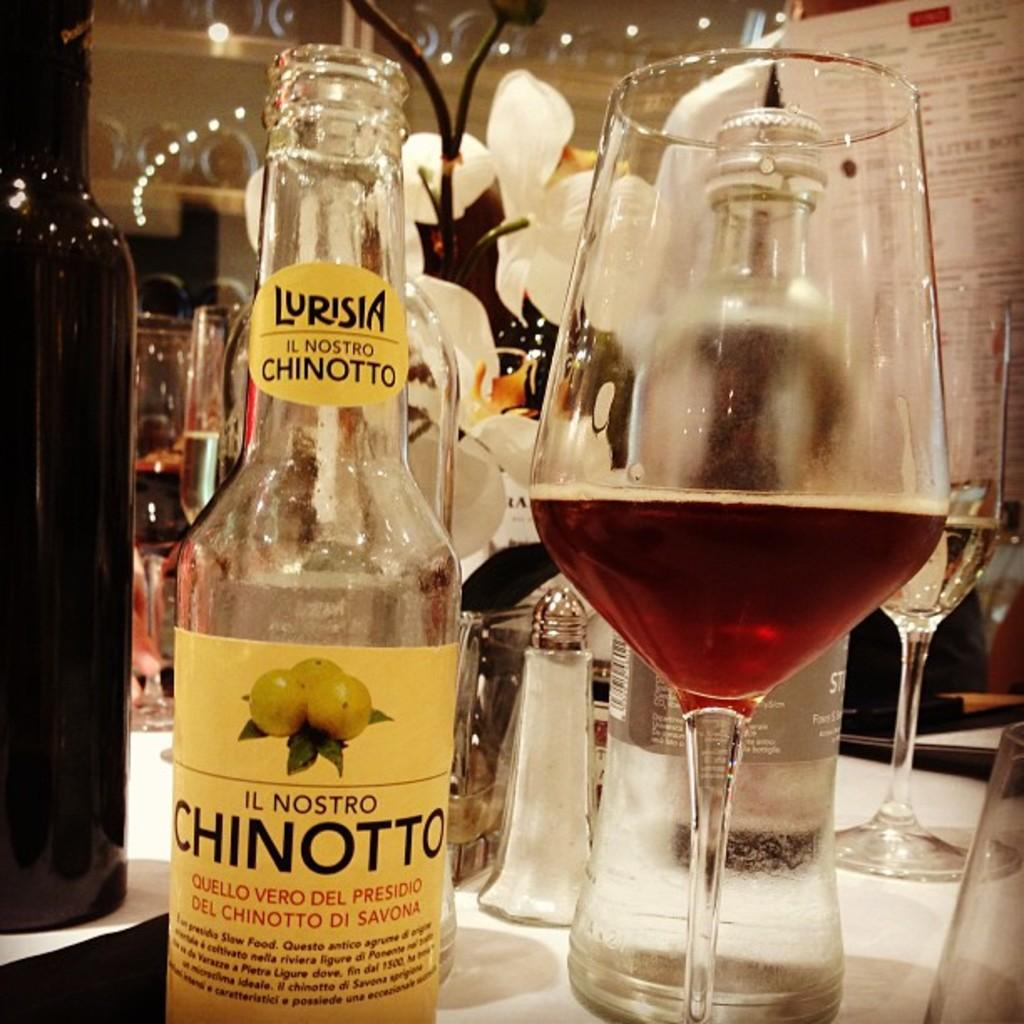What type of containers are present in the image? There are bottles in the image. What other type of container is present in the image? There is a wine glass in the image. Where are the bottles and wine glass located? The bottles and wine glass are on a table. What hobbies are the bottles and wine glass participating in within the image? The bottles and wine glass are not participating in any hobbies, as they are inanimate objects. 